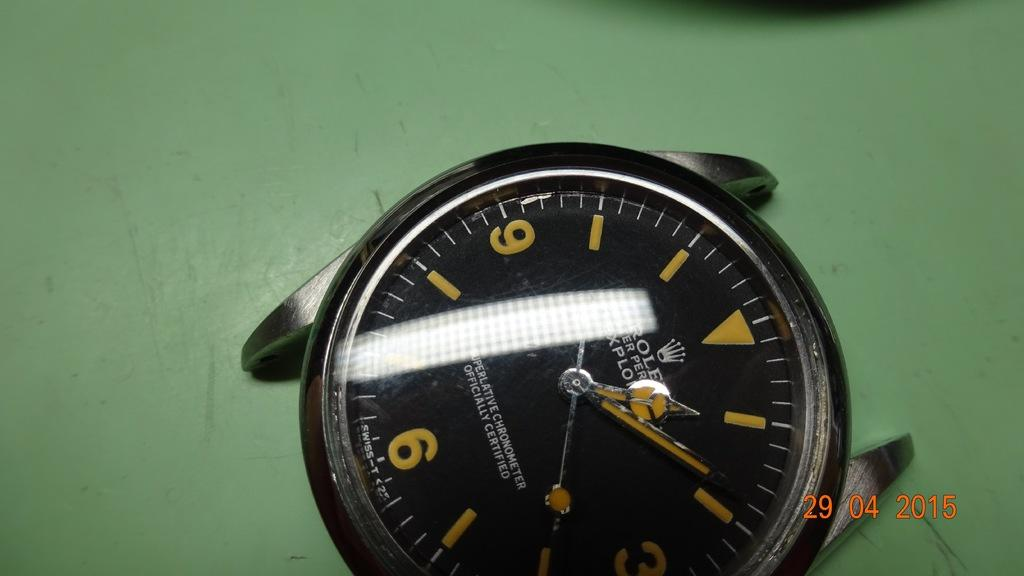What object is the main focus of the image? There is a watch in the image. What is the watch placed on? The watch is on a green color platform. Is there any text present in the image? Yes, there is text at the bottom of the image. What type of birthday celebration is depicted in the image? There is no birthday celebration depicted in the image; it features a watch on a green platform with text at the bottom. Can you see the queen in the image? There is no queen present in the image. 